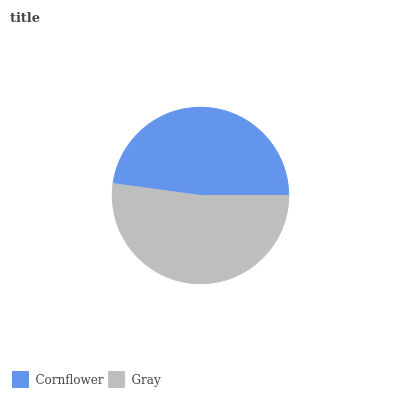Is Cornflower the minimum?
Answer yes or no. Yes. Is Gray the maximum?
Answer yes or no. Yes. Is Gray the minimum?
Answer yes or no. No. Is Gray greater than Cornflower?
Answer yes or no. Yes. Is Cornflower less than Gray?
Answer yes or no. Yes. Is Cornflower greater than Gray?
Answer yes or no. No. Is Gray less than Cornflower?
Answer yes or no. No. Is Gray the high median?
Answer yes or no. Yes. Is Cornflower the low median?
Answer yes or no. Yes. Is Cornflower the high median?
Answer yes or no. No. Is Gray the low median?
Answer yes or no. No. 